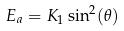Convert formula to latex. <formula><loc_0><loc_0><loc_500><loc_500>E _ { a } = K _ { 1 } \sin ^ { 2 } ( \theta )</formula> 